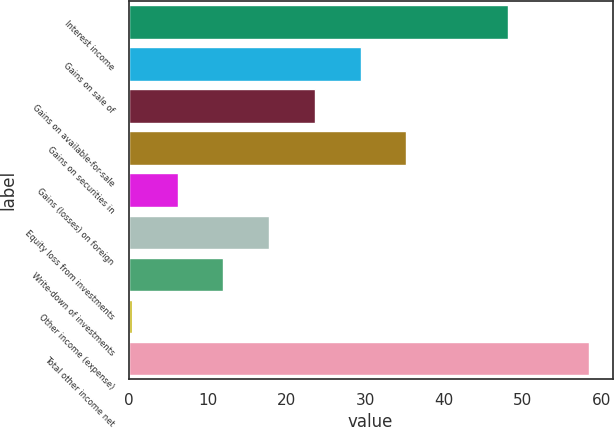<chart> <loc_0><loc_0><loc_500><loc_500><bar_chart><fcel>Interest income<fcel>Gains on sale of<fcel>Gains on available-for-sale<fcel>Gains on securities in<fcel>Gains (losses) on foreign<fcel>Equity loss from investments<fcel>Write-down of investments<fcel>Other income (expense)<fcel>Total other income net<nl><fcel>48.1<fcel>29.45<fcel>23.64<fcel>35.26<fcel>6.21<fcel>17.83<fcel>12.02<fcel>0.4<fcel>58.5<nl></chart> 